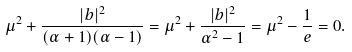Convert formula to latex. <formula><loc_0><loc_0><loc_500><loc_500>\mu ^ { 2 } + \frac { | b | ^ { 2 } } { ( \alpha + 1 ) ( \alpha - 1 ) } = \mu ^ { 2 } + \frac { | b | ^ { 2 } } { \alpha ^ { 2 } - 1 } = \mu ^ { 2 } - \frac { 1 } { e } = 0 .</formula> 